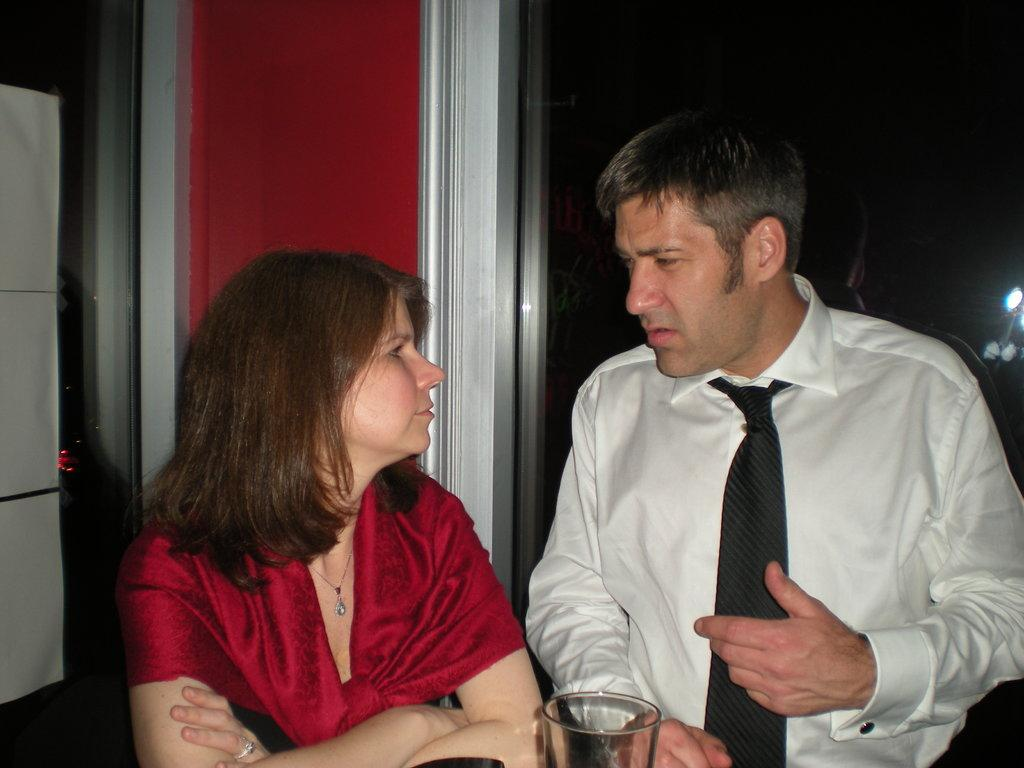How many people are in the image? There are two persons in the image. What is located in front of the persons? There is a glass in front of the persons. What is on top of the glass? There are papers on the glass. Can you describe the background of the image? There is a person and lights visible in the background of the image. What type of drug is being used by the person in the background? There is no indication of any drug use in the image; it only shows two persons, a glass, papers, and a person with lights in the background. 